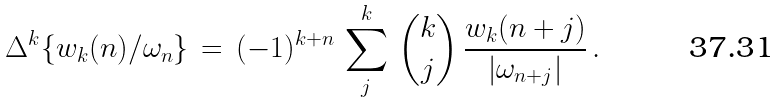Convert formula to latex. <formula><loc_0><loc_0><loc_500><loc_500>\Delta ^ { k } \{ w _ { k } ( n ) / \omega _ { n } \} \, = \, ( - 1 ) ^ { k + n } \, \sum _ { j } ^ { k } \, { { k } \choose { j } } \, \frac { w _ { k } ( n + j ) } { | \omega _ { n + j } | } \, .</formula> 